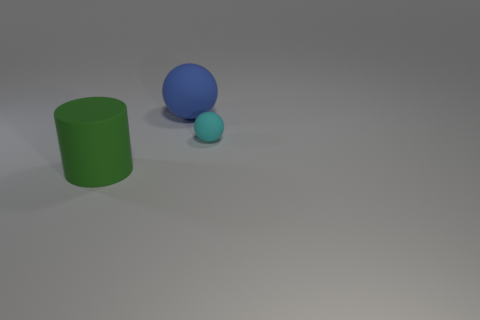Add 3 tiny cyan matte spheres. How many objects exist? 6 Subtract all spheres. How many objects are left? 1 Add 2 large gray shiny cylinders. How many large gray shiny cylinders exist? 2 Subtract 0 gray cubes. How many objects are left? 3 Subtract all blue spheres. Subtract all tiny cyan objects. How many objects are left? 1 Add 2 small cyan matte objects. How many small cyan matte objects are left? 3 